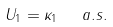<formula> <loc_0><loc_0><loc_500><loc_500>U _ { 1 } = \kappa _ { 1 } \ \ a . s .</formula> 